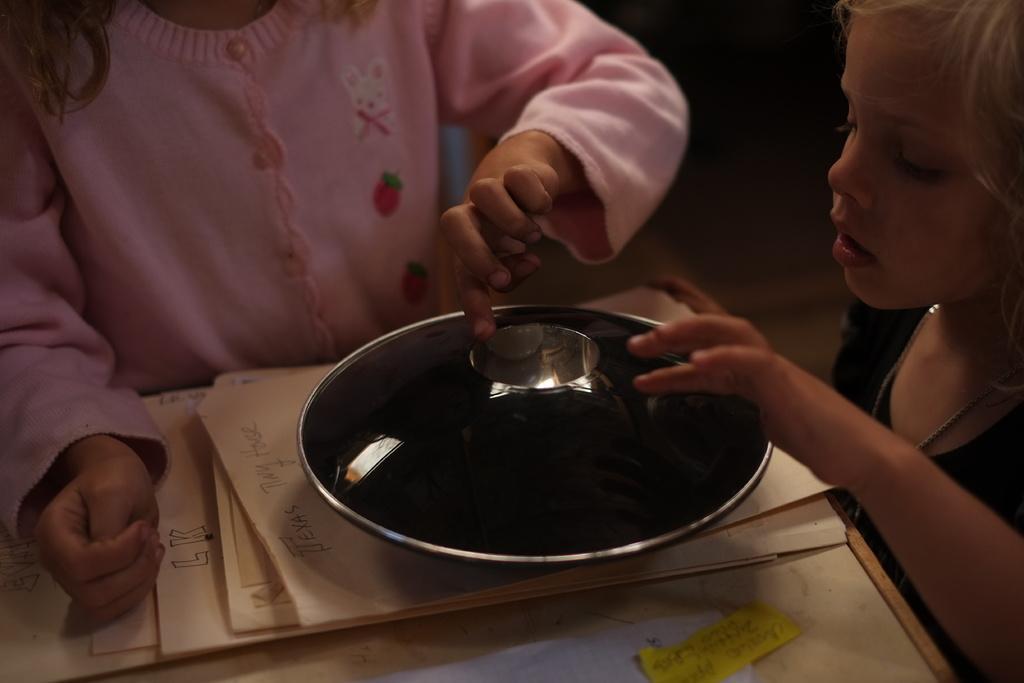Could you give a brief overview of what you see in this image? In this image we can see few people. There are few objects in the image. 